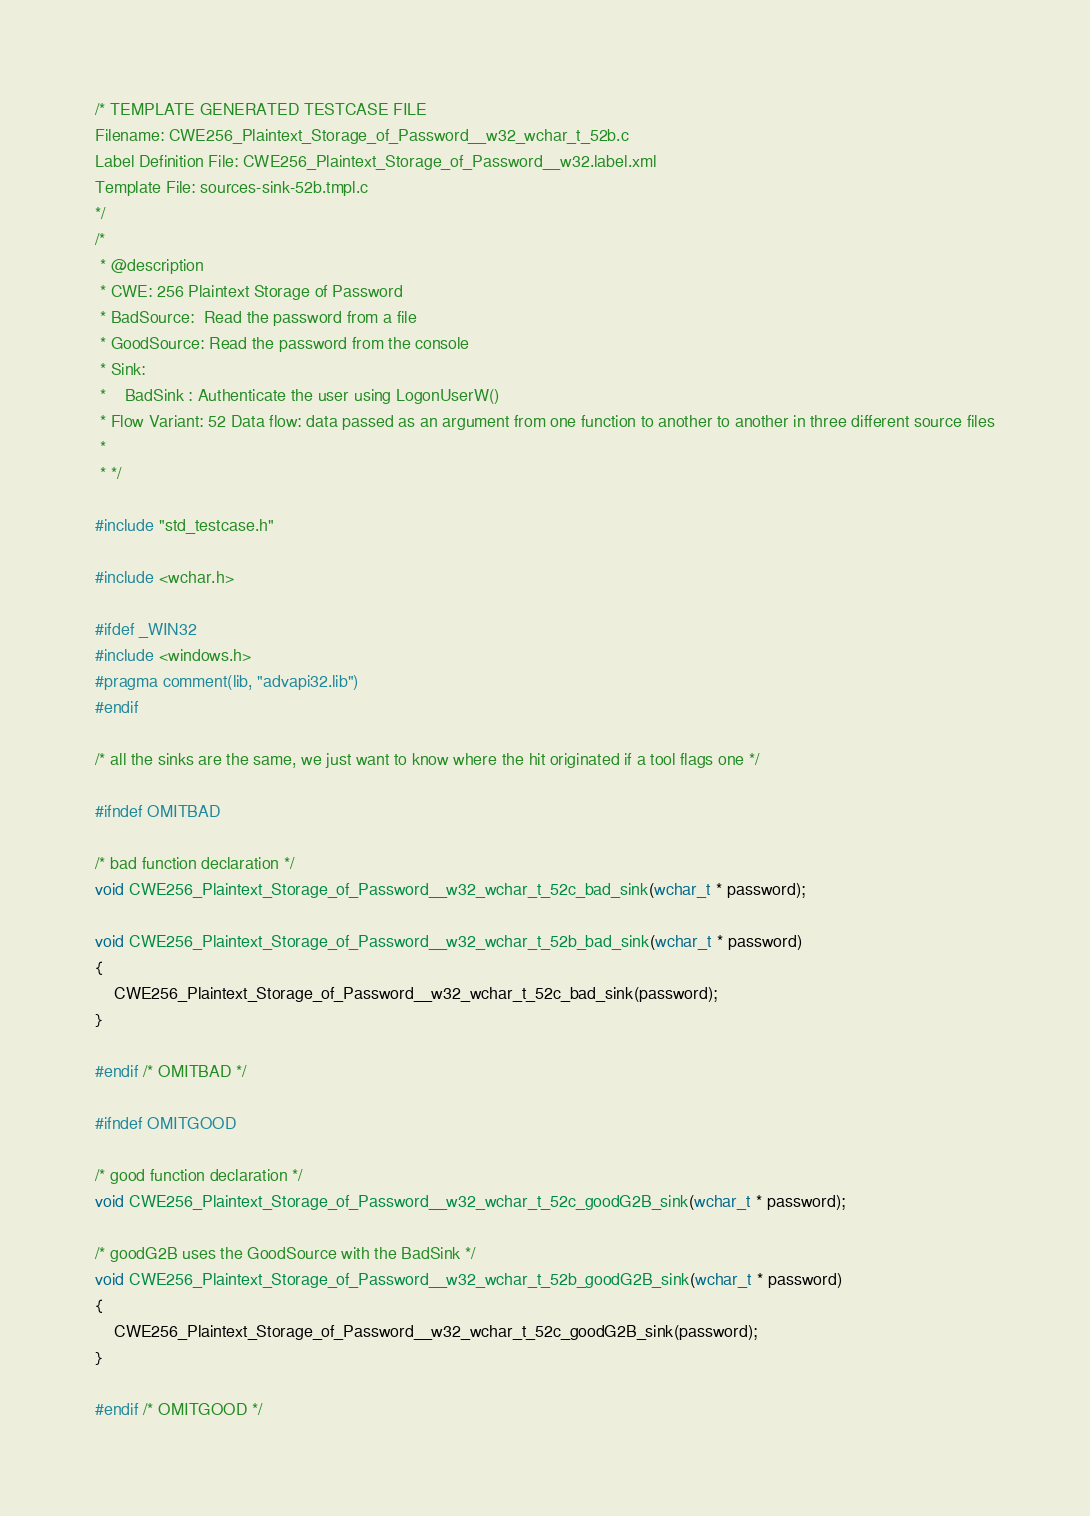Convert code to text. <code><loc_0><loc_0><loc_500><loc_500><_C_>/* TEMPLATE GENERATED TESTCASE FILE
Filename: CWE256_Plaintext_Storage_of_Password__w32_wchar_t_52b.c
Label Definition File: CWE256_Plaintext_Storage_of_Password__w32.label.xml
Template File: sources-sink-52b.tmpl.c
*/
/*
 * @description
 * CWE: 256 Plaintext Storage of Password
 * BadSource:  Read the password from a file
 * GoodSource: Read the password from the console
 * Sink:
 *    BadSink : Authenticate the user using LogonUserW()
 * Flow Variant: 52 Data flow: data passed as an argument from one function to another to another in three different source files
 *
 * */

#include "std_testcase.h"

#include <wchar.h>

#ifdef _WIN32
#include <windows.h>
#pragma comment(lib, "advapi32.lib")
#endif

/* all the sinks are the same, we just want to know where the hit originated if a tool flags one */

#ifndef OMITBAD

/* bad function declaration */
void CWE256_Plaintext_Storage_of_Password__w32_wchar_t_52c_bad_sink(wchar_t * password);

void CWE256_Plaintext_Storage_of_Password__w32_wchar_t_52b_bad_sink(wchar_t * password)
{
    CWE256_Plaintext_Storage_of_Password__w32_wchar_t_52c_bad_sink(password);
}

#endif /* OMITBAD */

#ifndef OMITGOOD

/* good function declaration */
void CWE256_Plaintext_Storage_of_Password__w32_wchar_t_52c_goodG2B_sink(wchar_t * password);

/* goodG2B uses the GoodSource with the BadSink */
void CWE256_Plaintext_Storage_of_Password__w32_wchar_t_52b_goodG2B_sink(wchar_t * password)
{
    CWE256_Plaintext_Storage_of_Password__w32_wchar_t_52c_goodG2B_sink(password);
}

#endif /* OMITGOOD */
</code> 